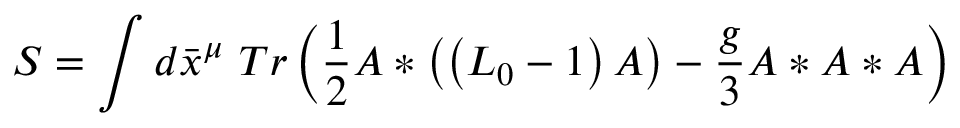Convert formula to latex. <formula><loc_0><loc_0><loc_500><loc_500>S = \int d \bar { x } ^ { \mu } T r \left ( \frac { 1 } { 2 } A \ast \left ( \left ( L _ { 0 } - 1 \right ) A \right ) - \frac { g } { 3 } A \ast A \ast A \right )</formula> 